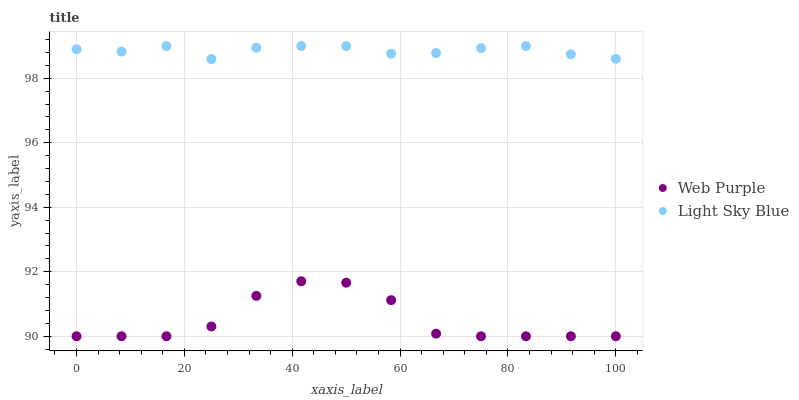Does Web Purple have the minimum area under the curve?
Answer yes or no. Yes. Does Light Sky Blue have the maximum area under the curve?
Answer yes or no. Yes. Does Light Sky Blue have the minimum area under the curve?
Answer yes or no. No. Is Light Sky Blue the smoothest?
Answer yes or no. Yes. Is Web Purple the roughest?
Answer yes or no. Yes. Is Light Sky Blue the roughest?
Answer yes or no. No. Does Web Purple have the lowest value?
Answer yes or no. Yes. Does Light Sky Blue have the lowest value?
Answer yes or no. No. Does Light Sky Blue have the highest value?
Answer yes or no. Yes. Is Web Purple less than Light Sky Blue?
Answer yes or no. Yes. Is Light Sky Blue greater than Web Purple?
Answer yes or no. Yes. Does Web Purple intersect Light Sky Blue?
Answer yes or no. No. 